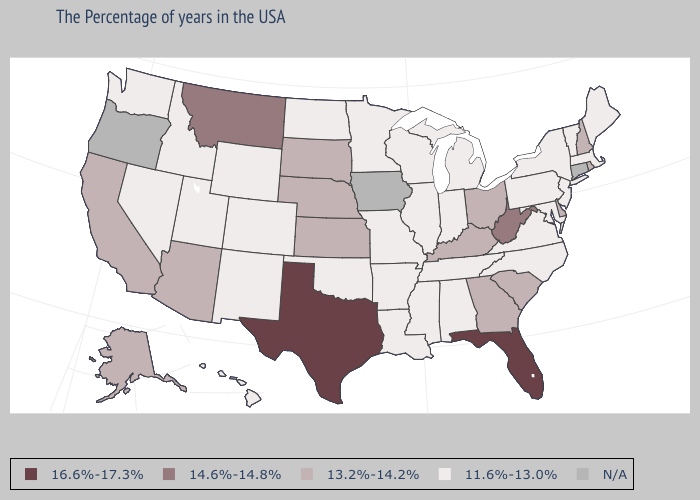Is the legend a continuous bar?
Answer briefly. No. Which states hav the highest value in the Northeast?
Quick response, please. Rhode Island, New Hampshire. What is the highest value in states that border Utah?
Answer briefly. 13.2%-14.2%. What is the value of West Virginia?
Answer briefly. 14.6%-14.8%. Does South Dakota have the highest value in the MidWest?
Short answer required. Yes. Name the states that have a value in the range 13.2%-14.2%?
Answer briefly. Rhode Island, New Hampshire, Delaware, South Carolina, Ohio, Georgia, Kentucky, Kansas, Nebraska, South Dakota, Arizona, California, Alaska. What is the value of Arkansas?
Answer briefly. 11.6%-13.0%. Does Washington have the highest value in the USA?
Quick response, please. No. What is the value of Maine?
Short answer required. 11.6%-13.0%. Is the legend a continuous bar?
Answer briefly. No. Which states have the highest value in the USA?
Give a very brief answer. Florida, Texas. Does the first symbol in the legend represent the smallest category?
Short answer required. No. What is the highest value in the USA?
Quick response, please. 16.6%-17.3%. 